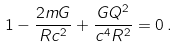Convert formula to latex. <formula><loc_0><loc_0><loc_500><loc_500>1 - \frac { 2 m G } { R c ^ { 2 } } + \frac { G Q ^ { 2 } } { c ^ { 4 } R ^ { 2 } } = 0 \, .</formula> 